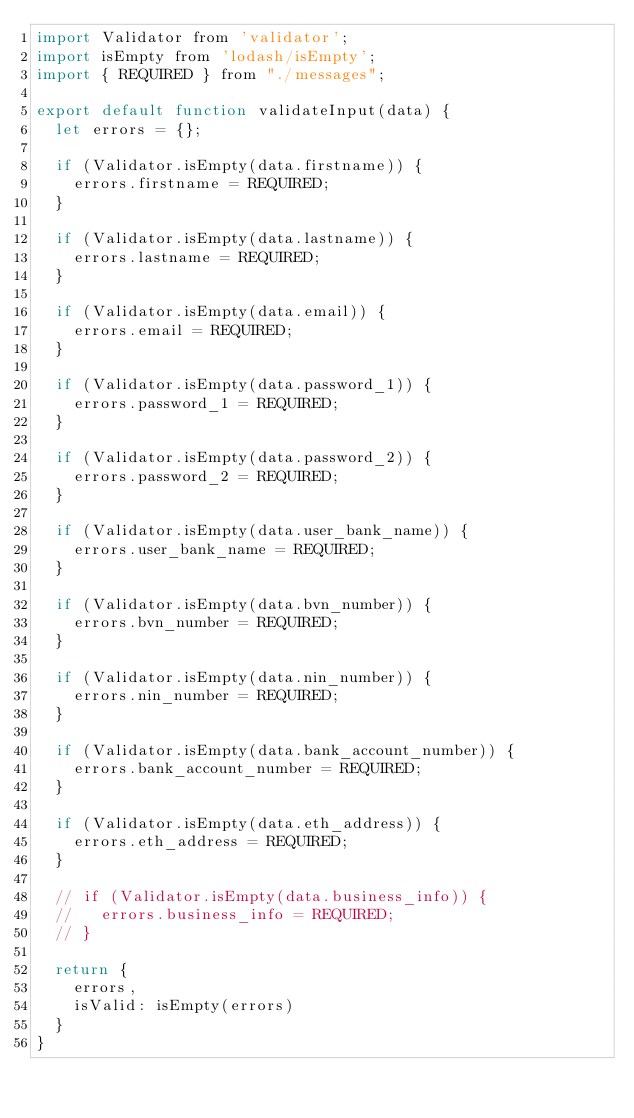<code> <loc_0><loc_0><loc_500><loc_500><_JavaScript_>import Validator from 'validator';
import isEmpty from 'lodash/isEmpty';
import { REQUIRED } from "./messages";

export default function validateInput(data) {
  let errors = {};

  if (Validator.isEmpty(data.firstname)) {
    errors.firstname = REQUIRED;
  }

  if (Validator.isEmpty(data.lastname)) {
    errors.lastname = REQUIRED;
  }

  if (Validator.isEmpty(data.email)) {
    errors.email = REQUIRED;
  }

  if (Validator.isEmpty(data.password_1)) {
    errors.password_1 = REQUIRED;
  }

  if (Validator.isEmpty(data.password_2)) {
    errors.password_2 = REQUIRED;
  }

  if (Validator.isEmpty(data.user_bank_name)) {
    errors.user_bank_name = REQUIRED;
  }

  if (Validator.isEmpty(data.bvn_number)) {
    errors.bvn_number = REQUIRED;
  }

  if (Validator.isEmpty(data.nin_number)) {
    errors.nin_number = REQUIRED;
  }

  if (Validator.isEmpty(data.bank_account_number)) {
    errors.bank_account_number = REQUIRED;
  }

  if (Validator.isEmpty(data.eth_address)) {
    errors.eth_address = REQUIRED;
  }

  // if (Validator.isEmpty(data.business_info)) {
  //   errors.business_info = REQUIRED;
  // }

  return {
    errors,
    isValid: isEmpty(errors)
  }
}
</code> 